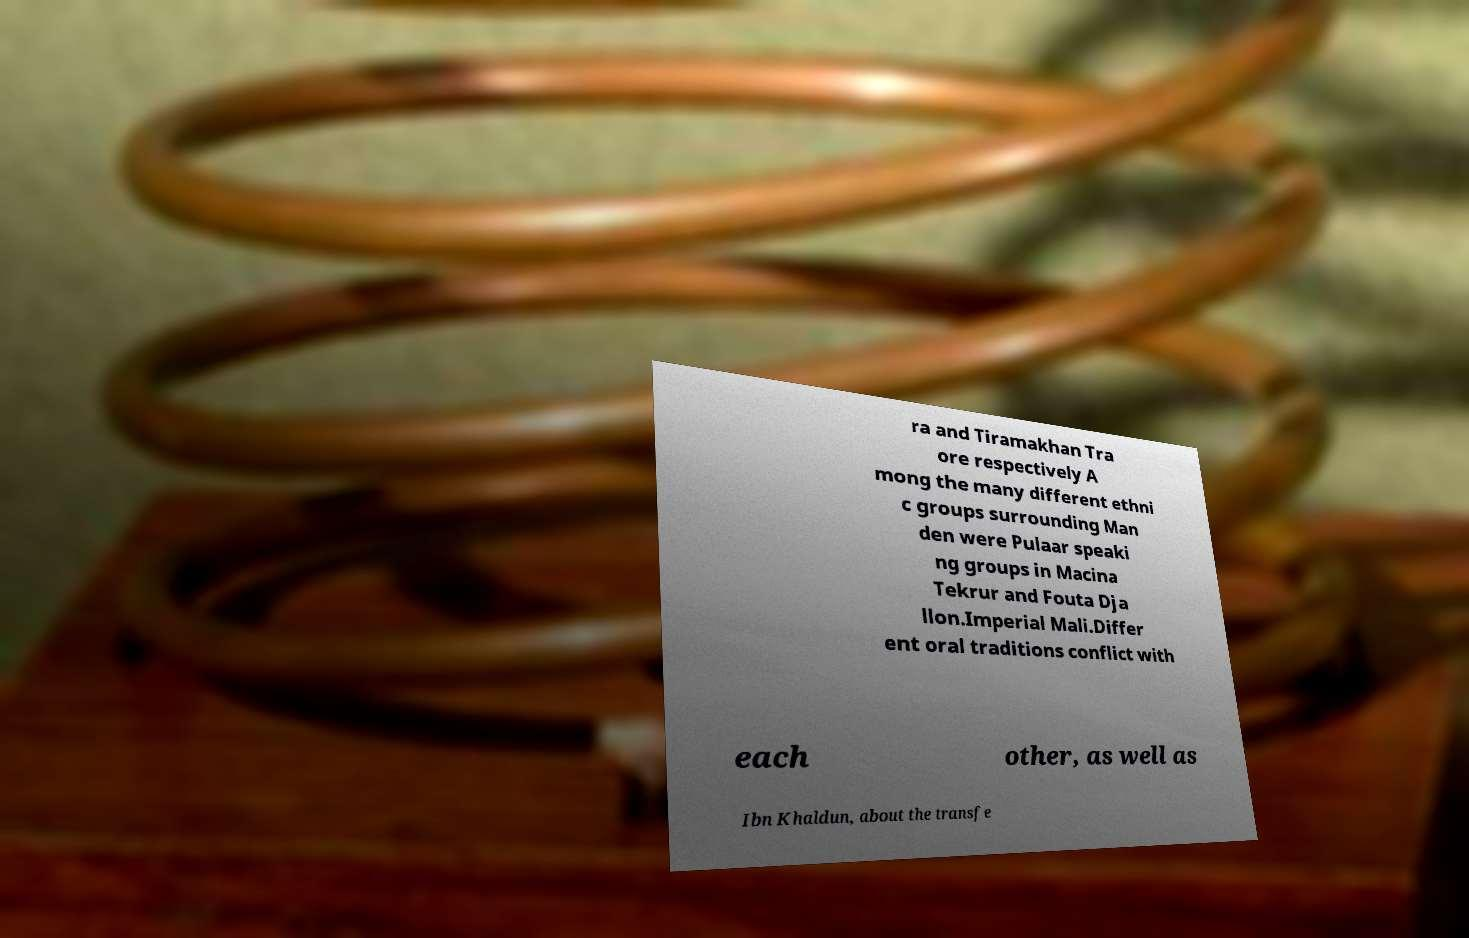Could you extract and type out the text from this image? ra and Tiramakhan Tra ore respectively A mong the many different ethni c groups surrounding Man den were Pulaar speaki ng groups in Macina Tekrur and Fouta Dja llon.Imperial Mali.Differ ent oral traditions conflict with each other, as well as Ibn Khaldun, about the transfe 